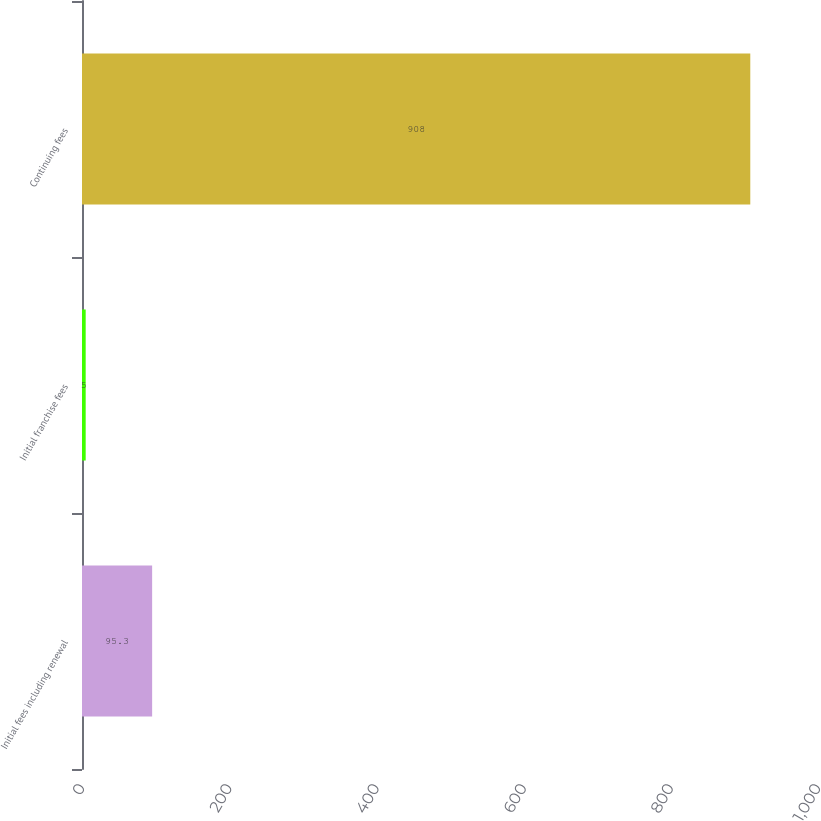<chart> <loc_0><loc_0><loc_500><loc_500><bar_chart><fcel>Initial fees including renewal<fcel>Initial franchise fees<fcel>Continuing fees<nl><fcel>95.3<fcel>5<fcel>908<nl></chart> 